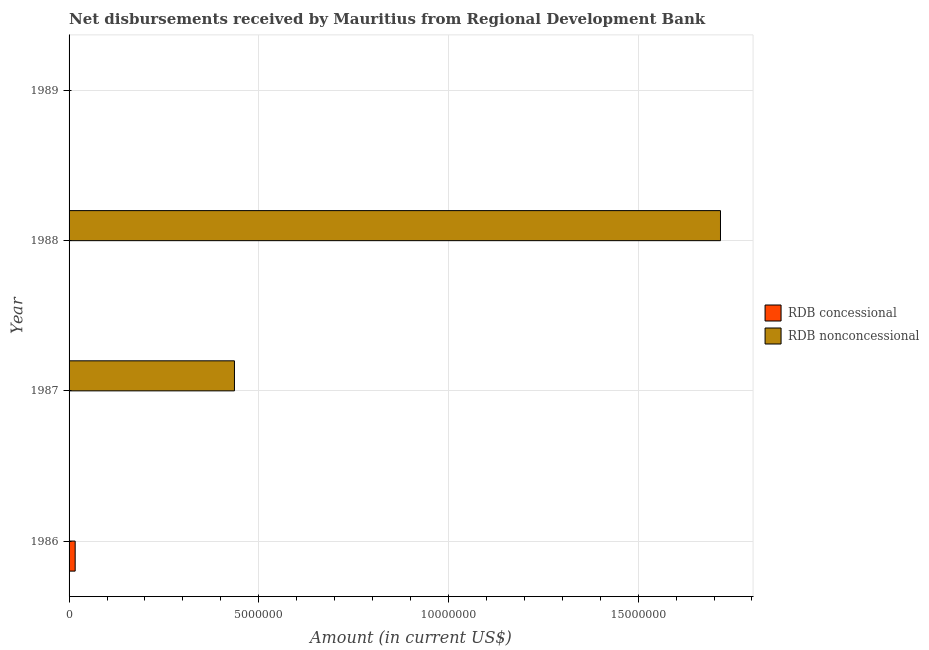How many different coloured bars are there?
Keep it short and to the point. 2. Are the number of bars per tick equal to the number of legend labels?
Provide a succinct answer. No. How many bars are there on the 4th tick from the bottom?
Offer a very short reply. 0. In how many cases, is the number of bars for a given year not equal to the number of legend labels?
Ensure brevity in your answer.  4. What is the net concessional disbursements from rdb in 1989?
Give a very brief answer. 0. Across all years, what is the maximum net non concessional disbursements from rdb?
Provide a short and direct response. 1.72e+07. Across all years, what is the minimum net non concessional disbursements from rdb?
Your answer should be compact. 0. What is the total net non concessional disbursements from rdb in the graph?
Ensure brevity in your answer.  2.15e+07. What is the difference between the net non concessional disbursements from rdb in 1987 and that in 1988?
Provide a short and direct response. -1.28e+07. What is the difference between the net concessional disbursements from rdb in 1986 and the net non concessional disbursements from rdb in 1987?
Provide a short and direct response. -4.20e+06. What is the average net concessional disbursements from rdb per year?
Give a very brief answer. 4.02e+04. In how many years, is the net concessional disbursements from rdb greater than 5000000 US$?
Offer a very short reply. 0. What is the difference between the highest and the lowest net non concessional disbursements from rdb?
Offer a terse response. 1.72e+07. How many bars are there?
Give a very brief answer. 3. Are all the bars in the graph horizontal?
Your answer should be compact. Yes. How many years are there in the graph?
Your answer should be very brief. 4. Are the values on the major ticks of X-axis written in scientific E-notation?
Keep it short and to the point. No. Does the graph contain any zero values?
Provide a short and direct response. Yes. Where does the legend appear in the graph?
Offer a terse response. Center right. How many legend labels are there?
Provide a short and direct response. 2. How are the legend labels stacked?
Provide a succinct answer. Vertical. What is the title of the graph?
Your response must be concise. Net disbursements received by Mauritius from Regional Development Bank. Does "Secondary school" appear as one of the legend labels in the graph?
Provide a succinct answer. No. What is the label or title of the Y-axis?
Offer a very short reply. Year. What is the Amount (in current US$) of RDB concessional in 1986?
Keep it short and to the point. 1.61e+05. What is the Amount (in current US$) in RDB nonconcessional in 1987?
Your response must be concise. 4.36e+06. What is the Amount (in current US$) of RDB concessional in 1988?
Provide a succinct answer. 0. What is the Amount (in current US$) of RDB nonconcessional in 1988?
Your answer should be very brief. 1.72e+07. Across all years, what is the maximum Amount (in current US$) of RDB concessional?
Provide a succinct answer. 1.61e+05. Across all years, what is the maximum Amount (in current US$) of RDB nonconcessional?
Your response must be concise. 1.72e+07. Across all years, what is the minimum Amount (in current US$) of RDB nonconcessional?
Make the answer very short. 0. What is the total Amount (in current US$) of RDB concessional in the graph?
Offer a very short reply. 1.61e+05. What is the total Amount (in current US$) of RDB nonconcessional in the graph?
Provide a short and direct response. 2.15e+07. What is the difference between the Amount (in current US$) of RDB nonconcessional in 1987 and that in 1988?
Your response must be concise. -1.28e+07. What is the difference between the Amount (in current US$) in RDB concessional in 1986 and the Amount (in current US$) in RDB nonconcessional in 1987?
Offer a very short reply. -4.20e+06. What is the difference between the Amount (in current US$) in RDB concessional in 1986 and the Amount (in current US$) in RDB nonconcessional in 1988?
Offer a very short reply. -1.70e+07. What is the average Amount (in current US$) of RDB concessional per year?
Offer a very short reply. 4.02e+04. What is the average Amount (in current US$) in RDB nonconcessional per year?
Offer a terse response. 5.38e+06. What is the ratio of the Amount (in current US$) in RDB nonconcessional in 1987 to that in 1988?
Give a very brief answer. 0.25. What is the difference between the highest and the lowest Amount (in current US$) of RDB concessional?
Your answer should be compact. 1.61e+05. What is the difference between the highest and the lowest Amount (in current US$) of RDB nonconcessional?
Offer a very short reply. 1.72e+07. 